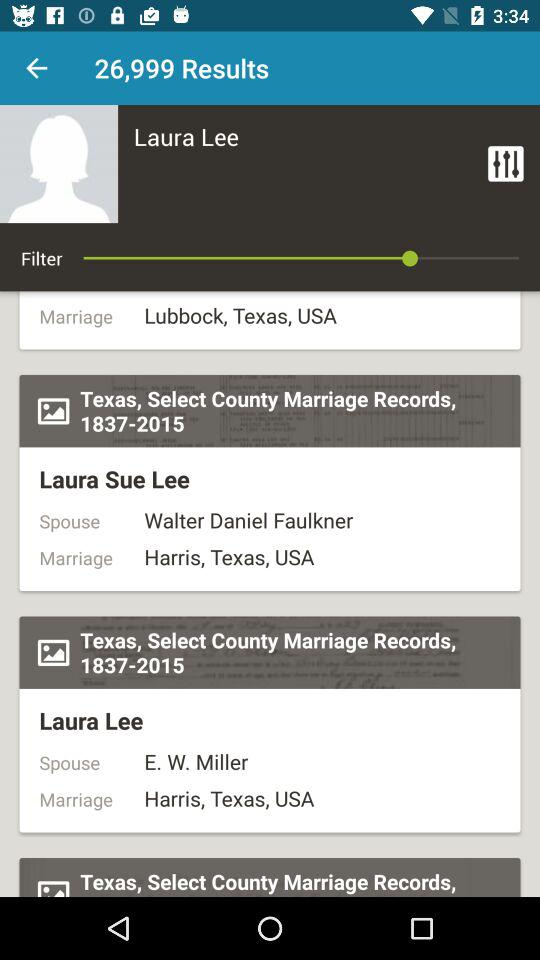What is the person's name? The person's name is Laura Lee. 